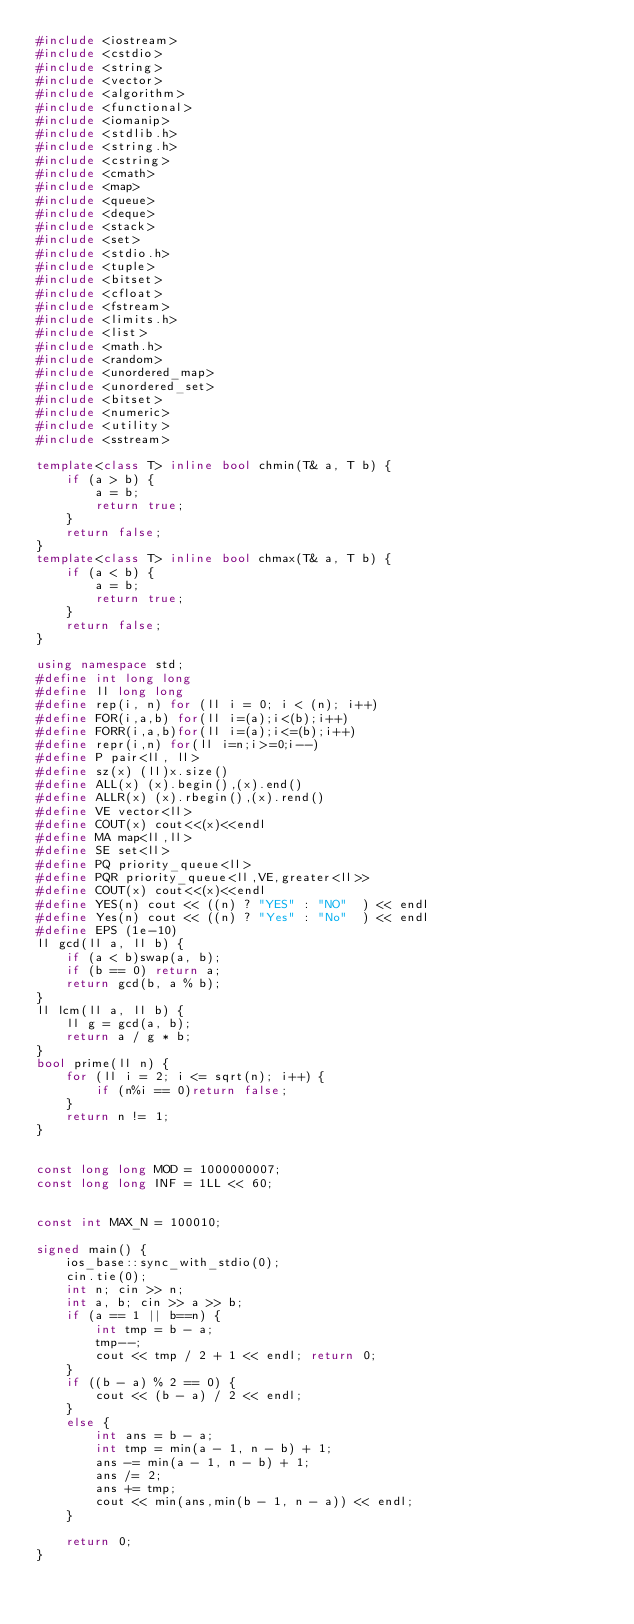Convert code to text. <code><loc_0><loc_0><loc_500><loc_500><_C++_>#include <iostream>
#include <cstdio>
#include <string>
#include <vector>
#include <algorithm>
#include <functional>
#include <iomanip>
#include <stdlib.h>
#include <string.h>
#include <cstring>
#include <cmath>
#include <map>
#include <queue>
#include <deque>
#include <stack>
#include <set>
#include <stdio.h>
#include <tuple>
#include <bitset>
#include <cfloat>
#include <fstream>
#include <limits.h>
#include <list>
#include <math.h>
#include <random>
#include <unordered_map>
#include <unordered_set>
#include <bitset>
#include <numeric>
#include <utility>
#include <sstream>

template<class T> inline bool chmin(T& a, T b) {
	if (a > b) {
		a = b;
		return true;
	}
	return false;
}
template<class T> inline bool chmax(T& a, T b) {
	if (a < b) {
		a = b;
		return true;
	}
	return false;
}

using namespace std;
#define int long long
#define ll long long
#define rep(i, n) for (ll i = 0; i < (n); i++)
#define FOR(i,a,b) for(ll i=(a);i<(b);i++)
#define FORR(i,a,b)for(ll i=(a);i<=(b);i++)
#define repr(i,n) for(ll i=n;i>=0;i--)
#define P pair<ll, ll>
#define sz(x) (ll)x.size()
#define ALL(x) (x).begin(),(x).end()
#define ALLR(x) (x).rbegin(),(x).rend()
#define VE vector<ll>
#define COUT(x) cout<<(x)<<endl
#define MA map<ll,ll>
#define SE set<ll>
#define PQ priority_queue<ll>
#define PQR priority_queue<ll,VE,greater<ll>>
#define COUT(x) cout<<(x)<<endl
#define YES(n) cout << ((n) ? "YES" : "NO"  ) << endl
#define Yes(n) cout << ((n) ? "Yes" : "No"  ) << endl
#define EPS (1e-10)
ll gcd(ll a, ll b) {
	if (a < b)swap(a, b);
	if (b == 0) return a;
	return gcd(b, a % b);
}
ll lcm(ll a, ll b) {
	ll g = gcd(a, b);
	return a / g * b;
}
bool prime(ll n) {
	for (ll i = 2; i <= sqrt(n); i++) {
		if (n%i == 0)return false;
	}
	return n != 1;
}


const long long MOD = 1000000007;
const long long INF = 1LL << 60;


const int MAX_N = 100010;

signed main() {
	ios_base::sync_with_stdio(0);
	cin.tie(0);
	int n; cin >> n;
	int a, b; cin >> a >> b;
	if (a == 1 || b==n) {
		int tmp = b - a;
		tmp--;
		cout << tmp / 2 + 1 << endl; return 0;
	}
	if ((b - a) % 2 == 0) {
		cout << (b - a) / 2 << endl;
	}
	else {
		int ans = b - a;
		int tmp = min(a - 1, n - b) + 1;
		ans -= min(a - 1, n - b) + 1;
		ans /= 2;
		ans += tmp;
		cout << min(ans,min(b - 1, n - a)) << endl;
	}

	return 0;
}</code> 